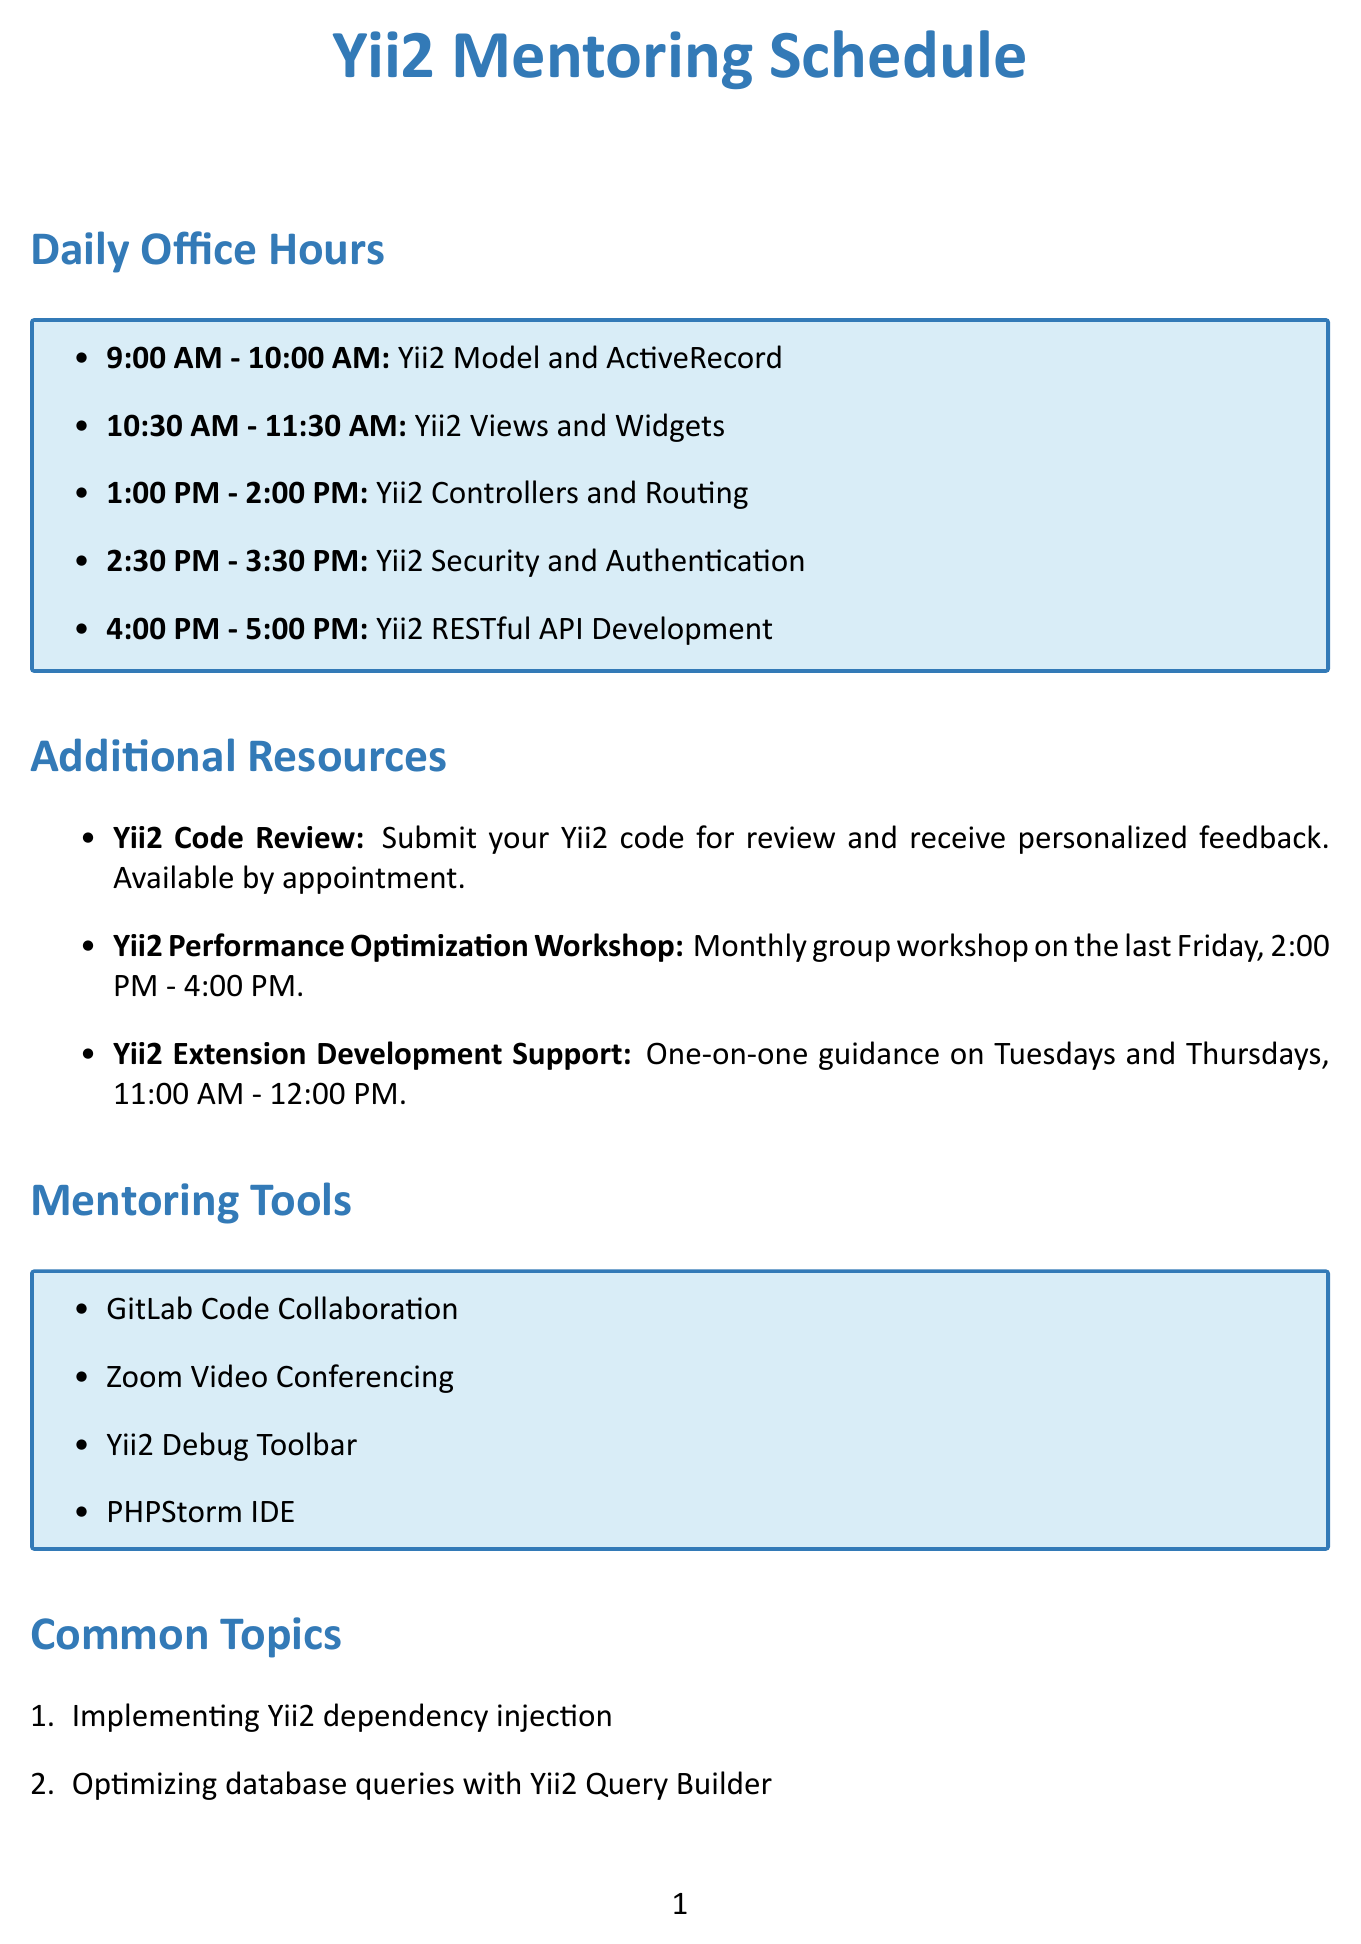What is the first focus area of the day? The first focus area listed in the schedule is Yii2 Model and ActiveRecord during the time slot of 9:00 AM - 10:00 AM.
Answer: Yii2 Model and ActiveRecord What time does the Yii2 Views and Widgets session start? The session for Yii2 Views and Widgets starts at 10:30 AM, as indicated in the schedule.
Answer: 10:30 AM How long is each mentoring session? Each mentoring session listed in the schedule lasts for one hour, except for the additional resources which have different availabilities.
Answer: One hour On which days can you receive Yii2 Extension Development Support? The availability for Yii2 Extension Development Support is mentioned as Tuesdays and Thursdays in the document.
Answer: Tuesdays and Thursdays What is the scheduled time for the Yii2 Performance Optimization Workshop? The workshop is scheduled for the last Friday of each month from 2:00 PM to 4:00 PM.
Answer: 2:00 PM - 4:00 PM How many focus areas are there in the daily office hours? The document lists a total of five focus areas covered in the daily office hours.
Answer: Five Which mentoring tool is recommended for efficient Yii2 coding? The document specifies PHPStorm IDE as the recommended development environment for efficient Yii2 coding and debugging.
Answer: PHPStorm IDE What is one common topic covered in the mentoring sessions? The document lists several common topics, such as implementing Yii2 dependency injection, which is one of the topics covered.
Answer: Implementing Yii2 dependency injection What type of tool is the Yii2 Debug Toolbar? The Yii2 Debug Toolbar is categorized as a mentoring tool used to analyze and optimize Yii2 application performance during troubleshooting.
Answer: Mentoring tool 